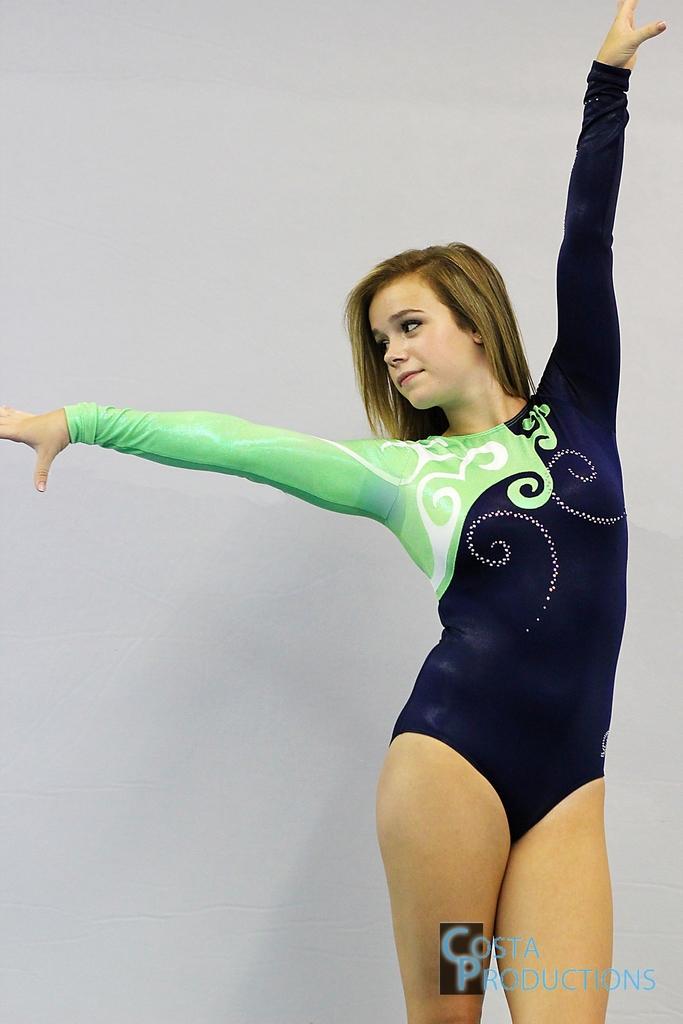Describe this image in one or two sentences. There is one woman standing as we can see on the right side of this image, and there is a white color wall in the background. There is a logo at the bottom of this image. 